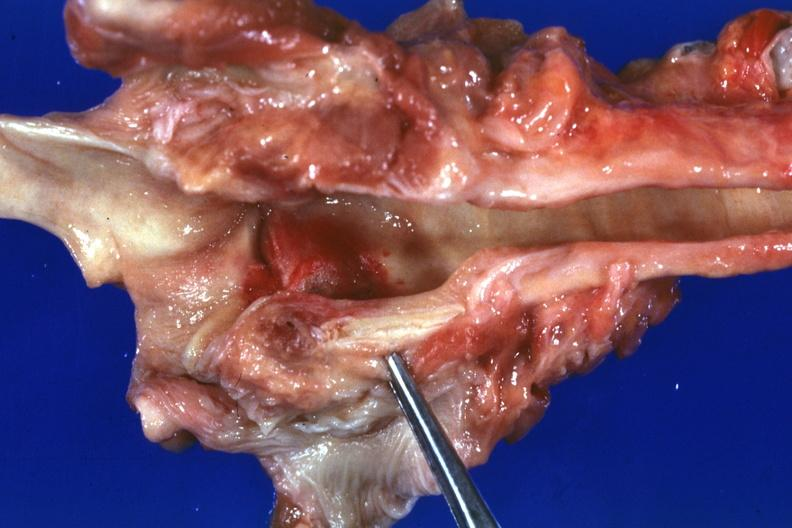why does this image show large hemorrhagic lesion about left cord?
Answer the question using a single word or phrase. Due to tube and candida possibly the portal of entry case of myeloproliferative syndrome with pancytopenia 